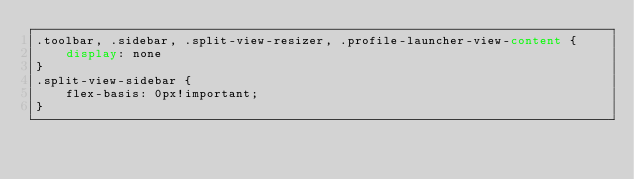<code> <loc_0><loc_0><loc_500><loc_500><_CSS_>.toolbar, .sidebar, .split-view-resizer, .profile-launcher-view-content {
	display: none
}
.split-view-sidebar {
	flex-basis: 0px!important;
}</code> 